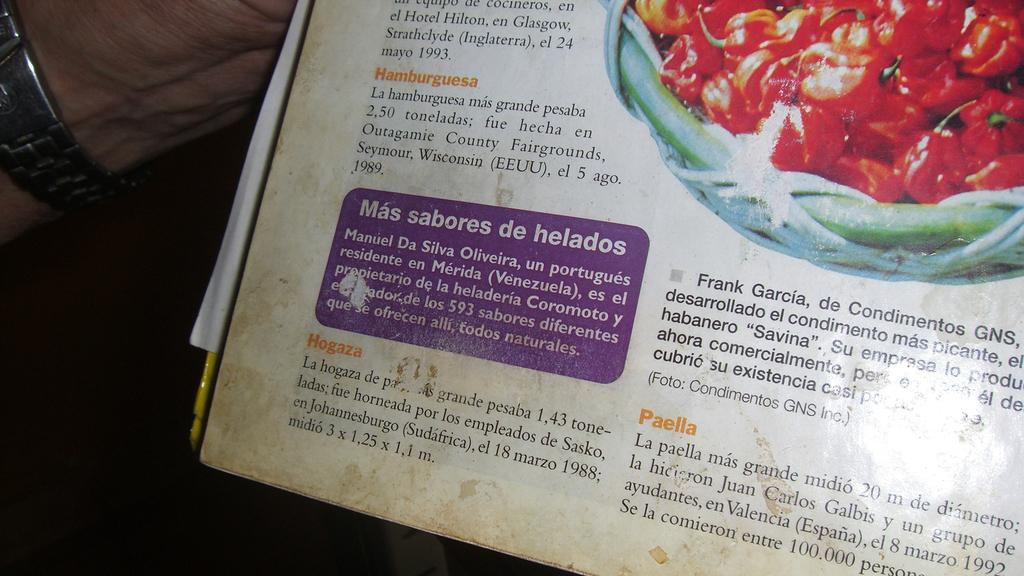<image>
Describe the image concisely. A splattered and stained page of a recipe book for Mas sabores de helados. 